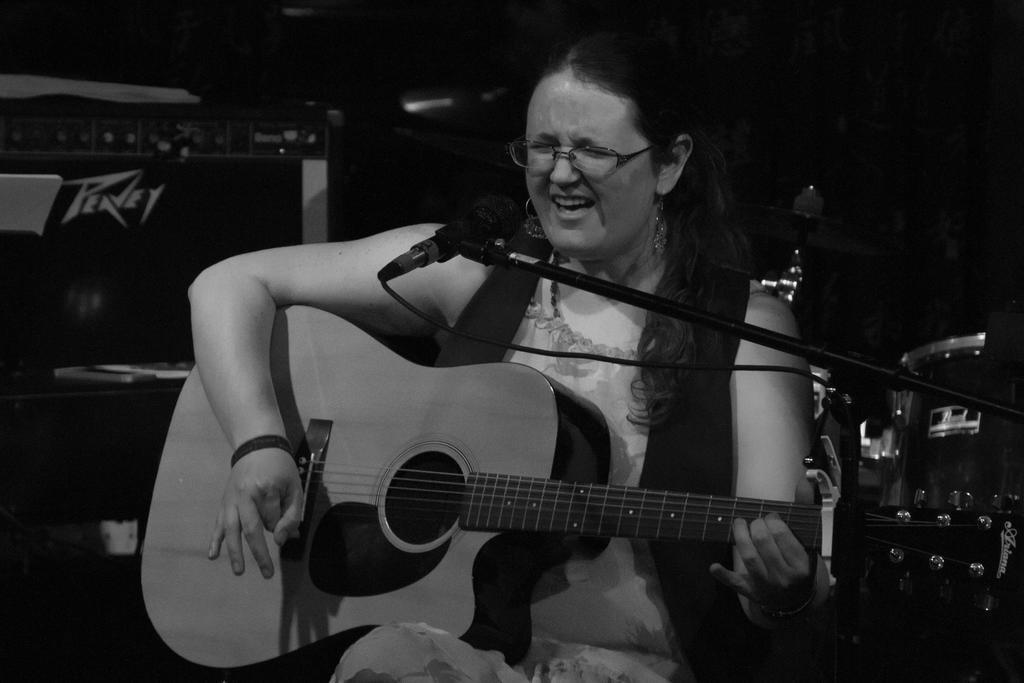Can you describe this image briefly? A woman is singing with a mic in front of her while playing a guitar. 